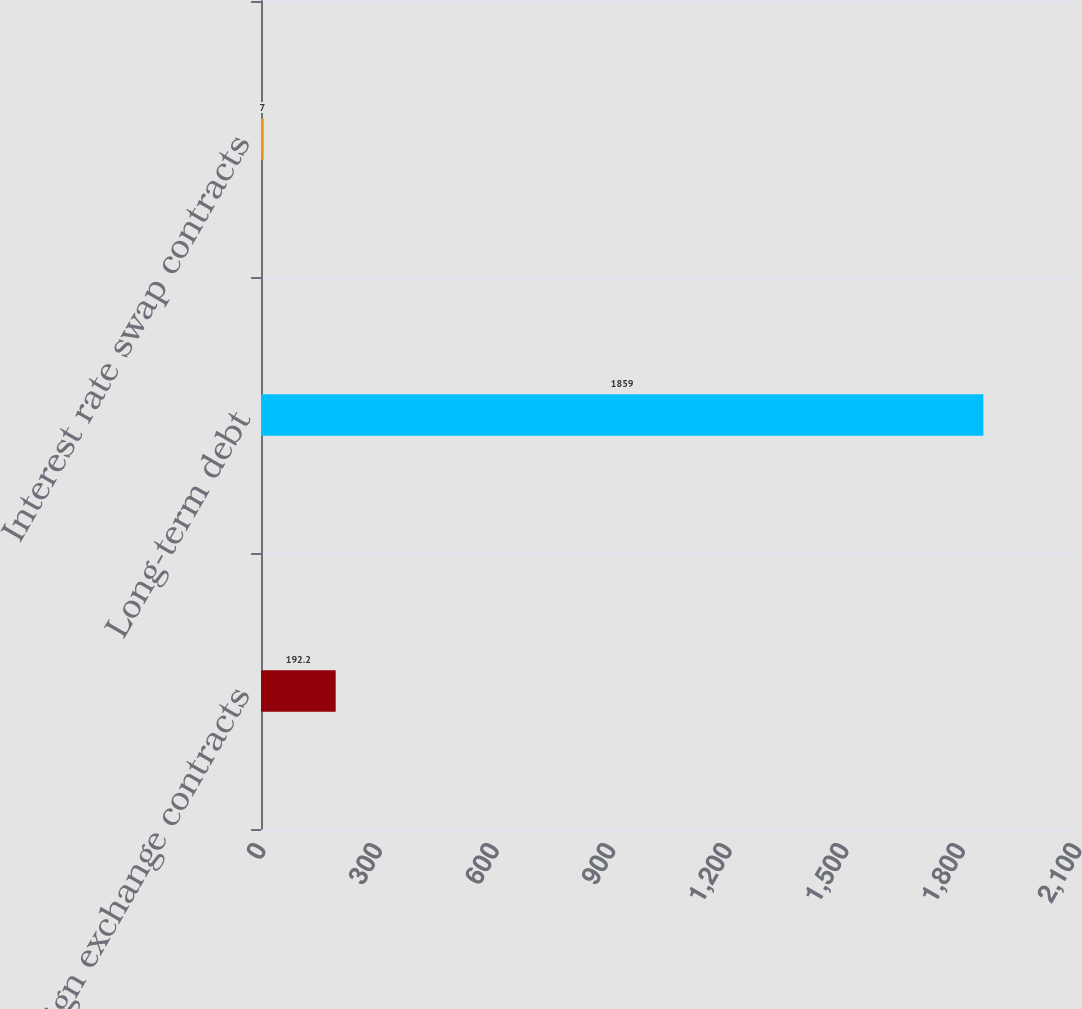Convert chart to OTSL. <chart><loc_0><loc_0><loc_500><loc_500><bar_chart><fcel>Foreign exchange contracts<fcel>Long-term debt<fcel>Interest rate swap contracts<nl><fcel>192.2<fcel>1859<fcel>7<nl></chart> 